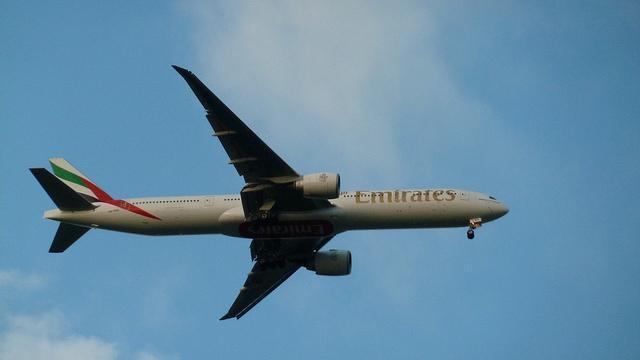How many colors are visible on the plane?
Give a very brief answer. 4. 